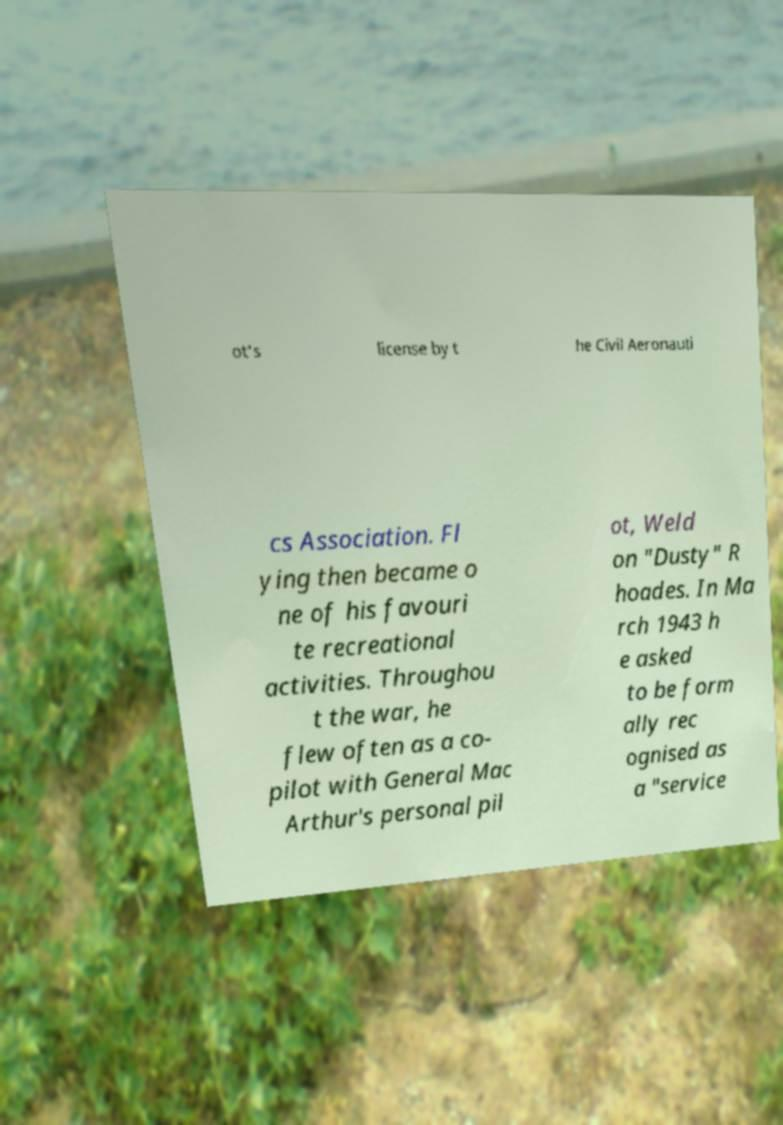Could you assist in decoding the text presented in this image and type it out clearly? ot's license by t he Civil Aeronauti cs Association. Fl ying then became o ne of his favouri te recreational activities. Throughou t the war, he flew often as a co- pilot with General Mac Arthur's personal pil ot, Weld on "Dusty" R hoades. In Ma rch 1943 h e asked to be form ally rec ognised as a "service 